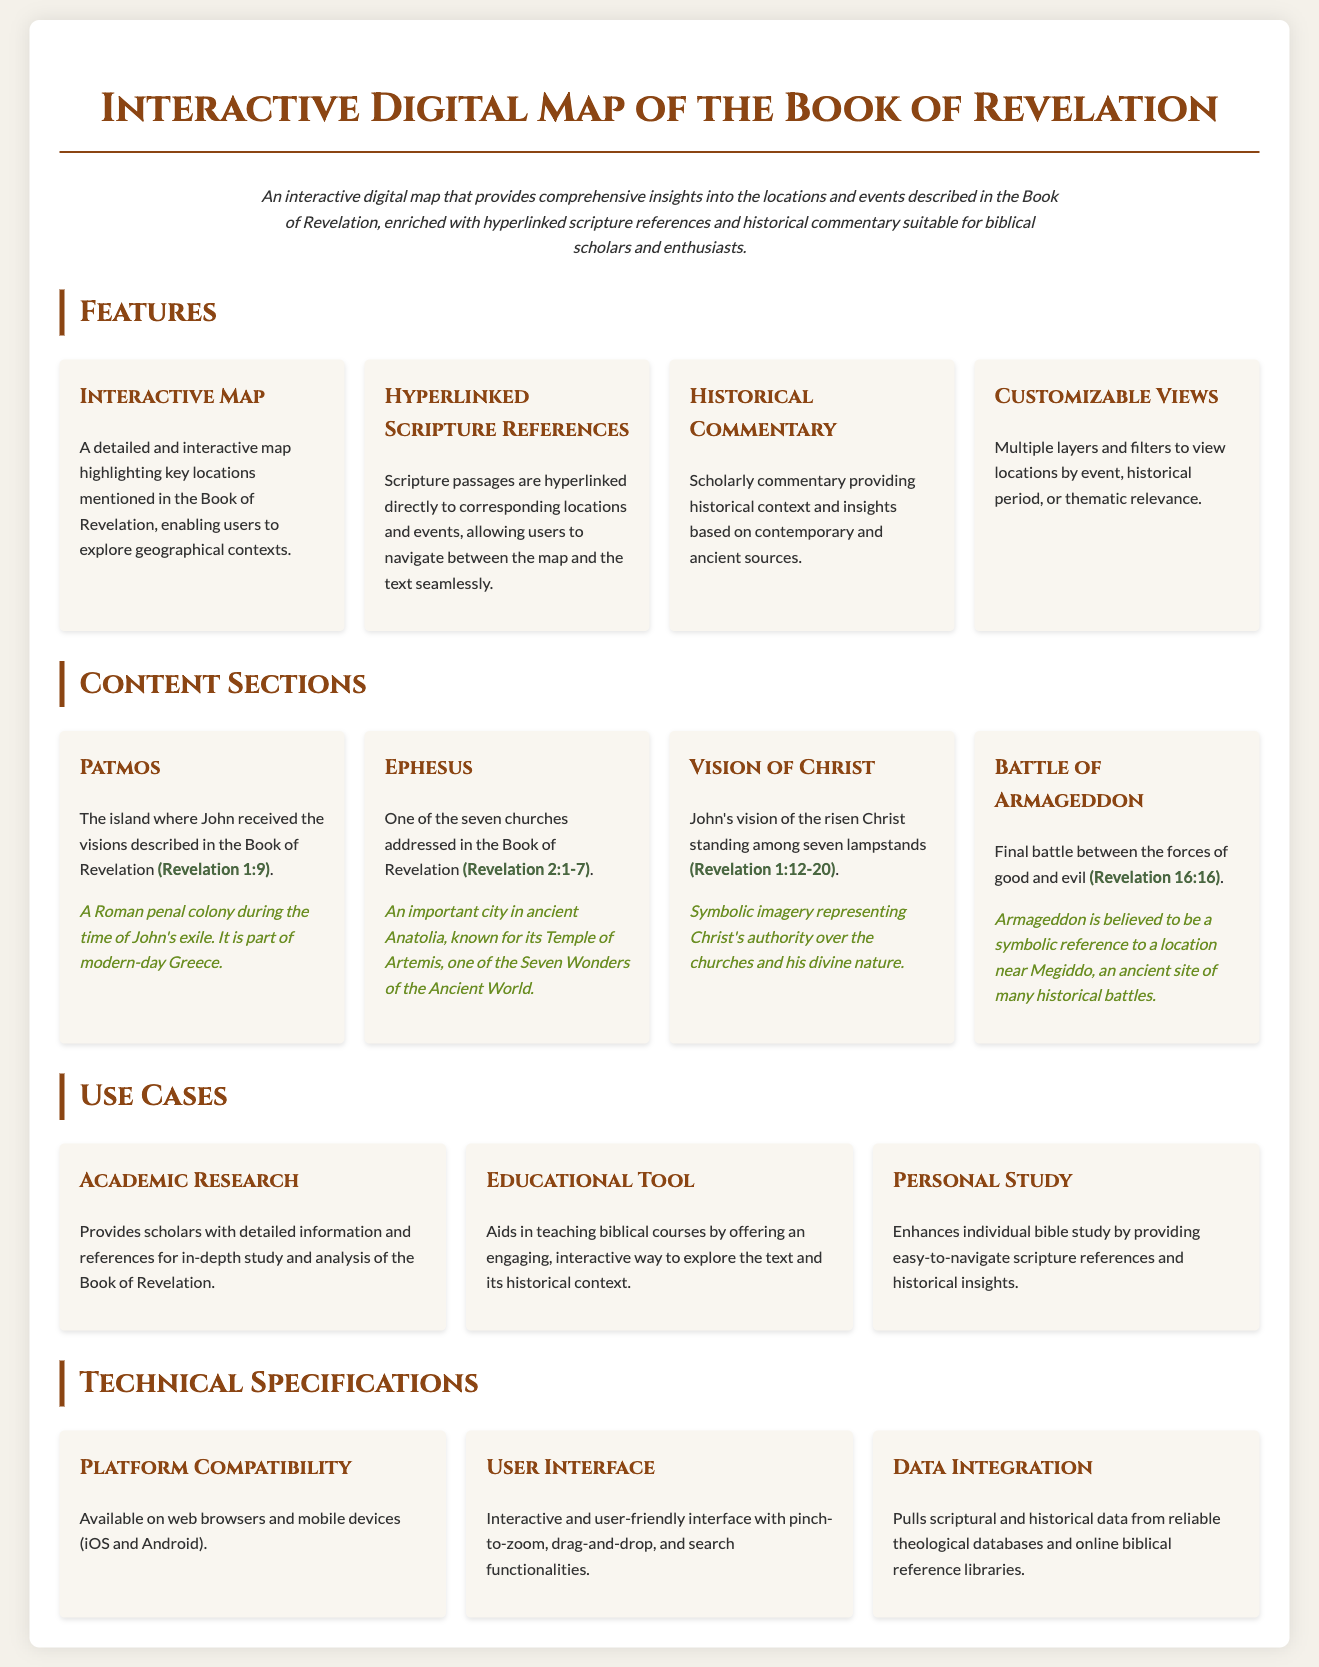what is the title of the product? The title of the product is prominently displayed at the top of the document.
Answer: Interactive Digital Map of the Book of Revelation how many churches are addressed in the Book of Revelation? The content section for Ephesus mentions it as one of seven churches.
Answer: seven churches what is one use case for the digital map? This is specifically mentioned as a way it can be utilized in the document.
Answer: Academic Research what does the interactive map highlight? The document specifies what the interactive map focuses on.
Answer: key locations which historical period is associated with Patmos? The historical context section mentions this information about Patmos.
Answer: Roman penal colony what feature allows users to see locations by theme? The feature section discusses capabilities related to customization.
Answer: Customizable Views how is the user interface described? The document contains a specific section regarding user interface characteristics.
Answer: Interactive and user-friendly what platforms are compatible with the product? There is a technical specification that mentions platform compatibility.
Answer: web browsers and mobile devices what is included alongside hyperlinked scripture references? The document lists accompanying elements related to scripture references.
Answer: historical commentary 